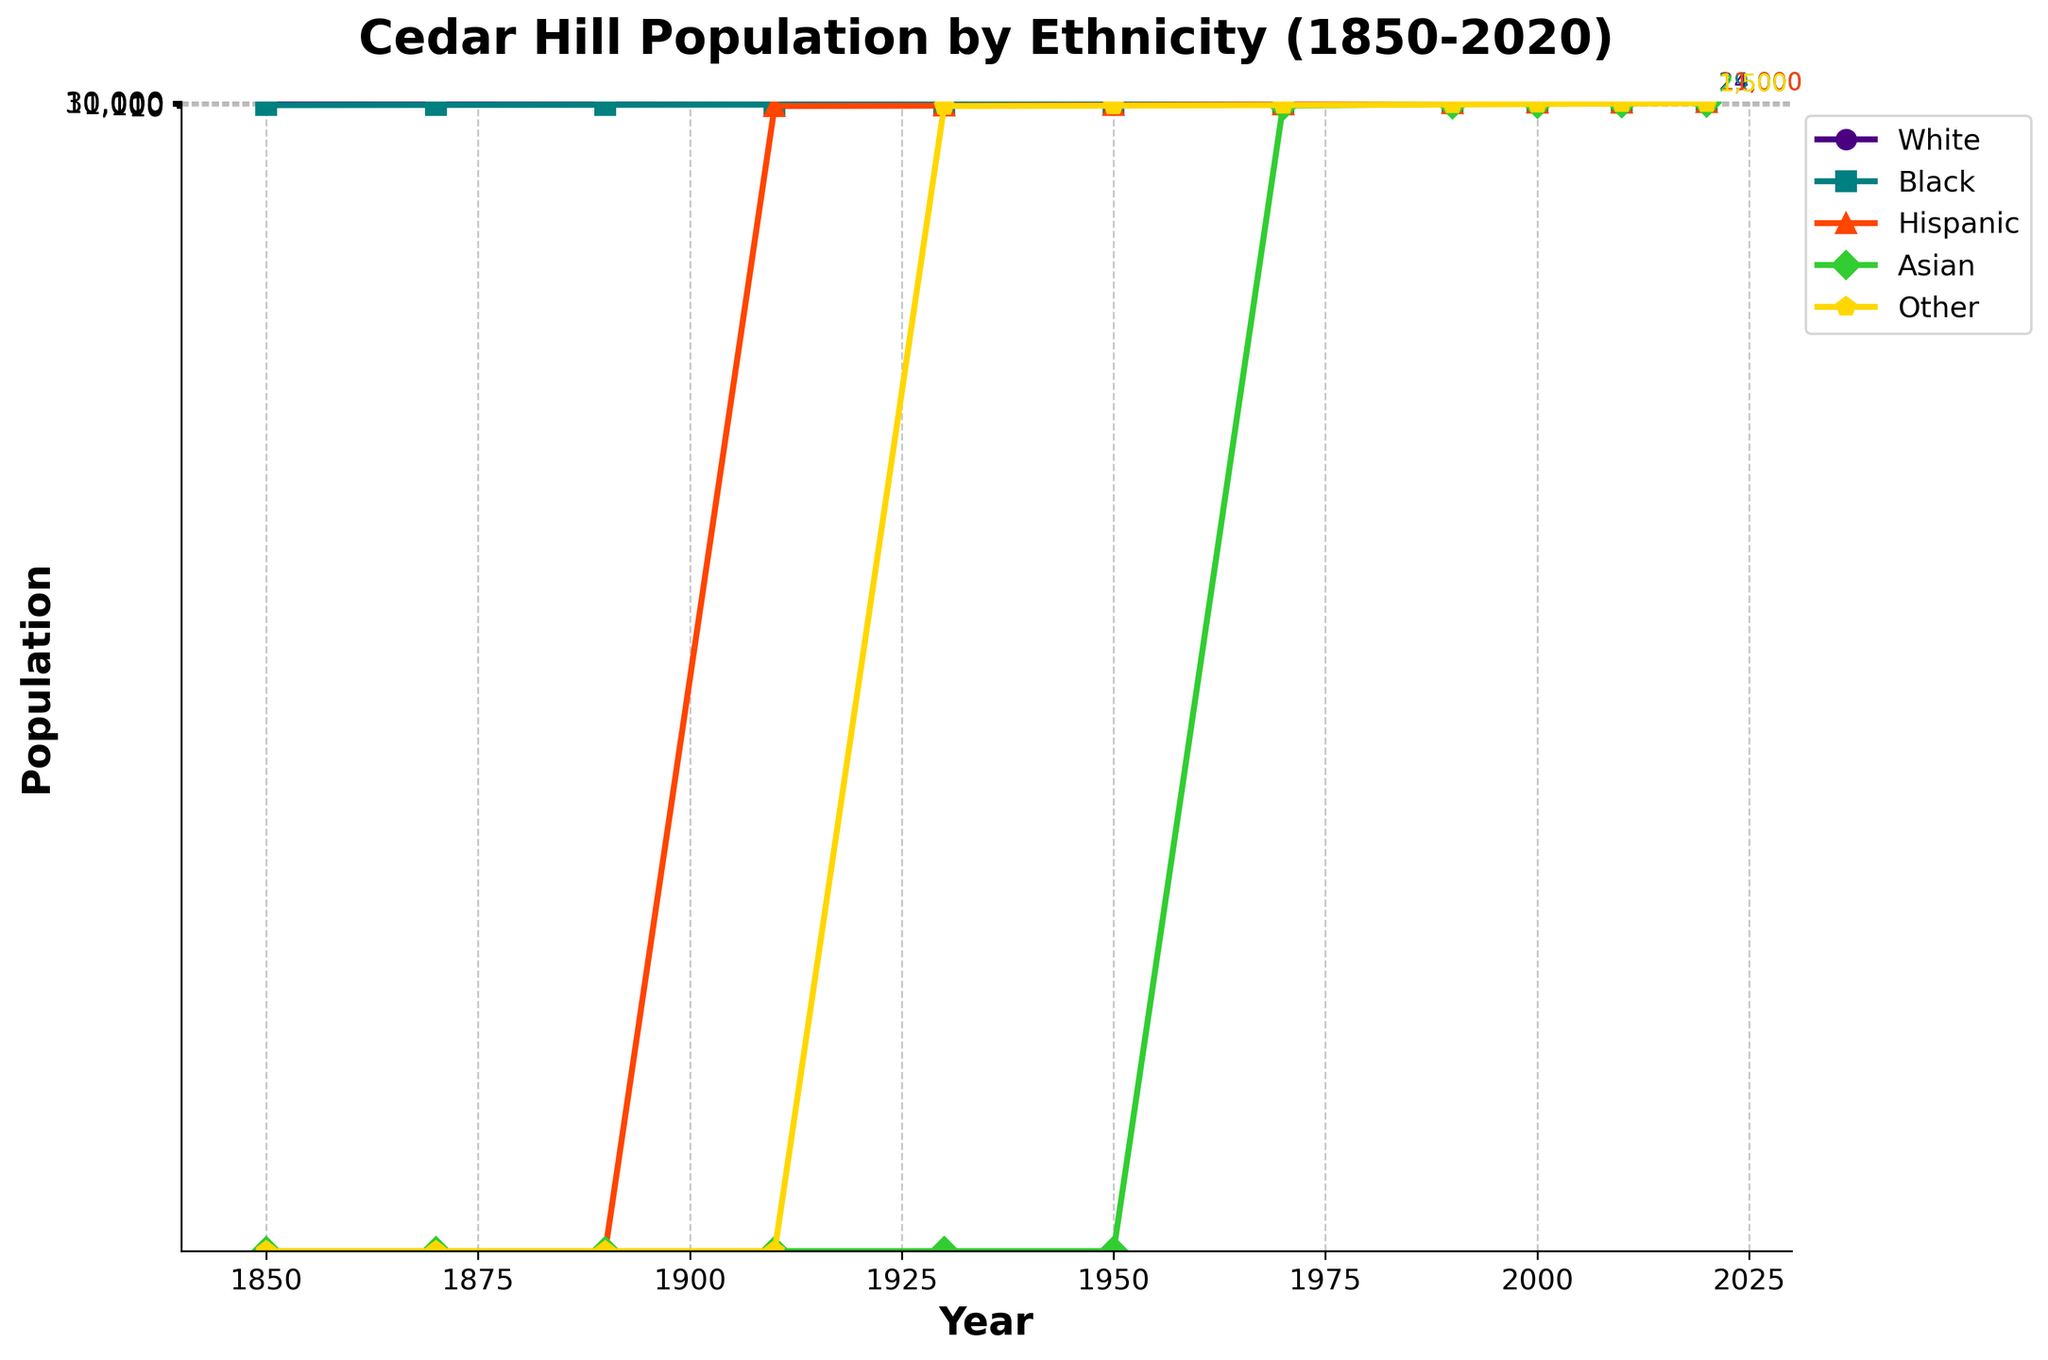What was the population of Cedar Hill in 1950 for the 'White' and 'Black' ethnicities combined? The 'White' population in 1950 was 1,200, and the 'Black' population was 300. Adding these together: 1,200 + 300 = 1,500.
Answer: 1,500 Which ethnicity showed the greatest increase in population between 1990 and 2020? Looking at the population values in 1990 and 2020, the 'Black' ethnicity increased from 3,500 to 19,000, which is the largest increase among all ethnicities.
Answer: Black Between which two consecutive decades did the 'Hispanic' population show the largest increase? By examining the Hispanic population numbers, the largest increase occurred between 2000 (3,000) and 2010 (7,000). The increase is 7,000 - 3,000 = 4,000.
Answer: 2000 to 2010 In which year did the 'Asian' population first appear in the data? The 'Asian' population first appears in 1970 with a population of 10.
Answer: 1970 How does the 'Other' population in 2020 compare to its population in 1950? The population for 'Other' in 1950 was 10 and in 2020 it was 1,500. The 2020 population is significantly larger.
Answer: Larger Which ethnicity had the smallest population in 1990, and what was the population value? The 'Asian' ethnicity had the smallest population in 1990, with a population of 200.
Answer: Asian, 200 What is the total population of Cedar Hill in 2020 according to the figure? Summing up the populations for all ethnicities in 2020: 24,000 (White) + 19,000 (Black) + 11,000 (Hispanic) + 2,500 (Asian) + 1,500 (Other) = 58,000.
Answer: 58,000 How many times did the 'White' population increase from 1850 to its peak in 2010? The 'White' population in 1850 was 120 and it peaked at 26,000 in 2010. The increase is 26,000 / 120 = 216.67 times.
Answer: 216.67 times Compare the rate of growth of the 'White' and 'Hispanic' populations from 1950 to 1970. Which grew faster? The 'White' population grew from 1,200 to 2,800, an increase of 1,600. The 'Hispanic' population grew from 30 to 100, an increase of 70. In relative terms, the 'Hispanic' population had a greater rate of growth (more than tripling) compared to the 'White' population (a little over doubling).
Answer: Hispanic grew faster 